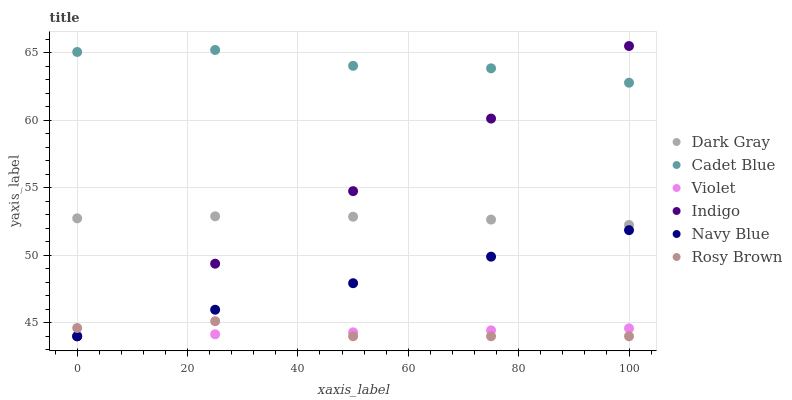Does Violet have the minimum area under the curve?
Answer yes or no. Yes. Does Cadet Blue have the maximum area under the curve?
Answer yes or no. Yes. Does Indigo have the minimum area under the curve?
Answer yes or no. No. Does Indigo have the maximum area under the curve?
Answer yes or no. No. Is Indigo the smoothest?
Answer yes or no. Yes. Is Cadet Blue the roughest?
Answer yes or no. Yes. Is Navy Blue the smoothest?
Answer yes or no. No. Is Navy Blue the roughest?
Answer yes or no. No. Does Indigo have the lowest value?
Answer yes or no. Yes. Does Dark Gray have the lowest value?
Answer yes or no. No. Does Indigo have the highest value?
Answer yes or no. Yes. Does Navy Blue have the highest value?
Answer yes or no. No. Is Navy Blue less than Cadet Blue?
Answer yes or no. Yes. Is Cadet Blue greater than Rosy Brown?
Answer yes or no. Yes. Does Violet intersect Indigo?
Answer yes or no. Yes. Is Violet less than Indigo?
Answer yes or no. No. Is Violet greater than Indigo?
Answer yes or no. No. Does Navy Blue intersect Cadet Blue?
Answer yes or no. No. 